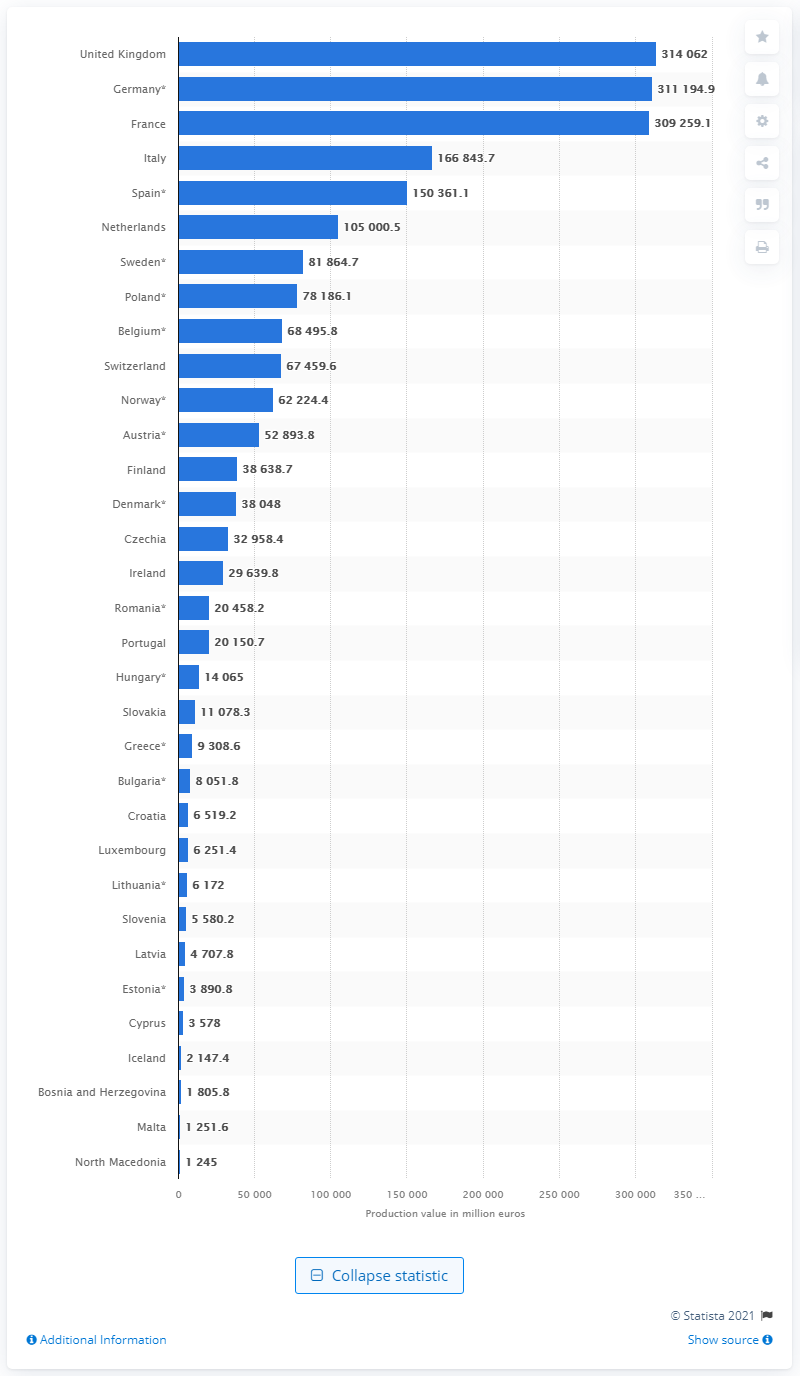Outline some significant characteristics in this image. In 2018, the production value of Germany's construction industry was 314,062,000. The production value of the construction industry in the UK in 2018 was 314,062. 